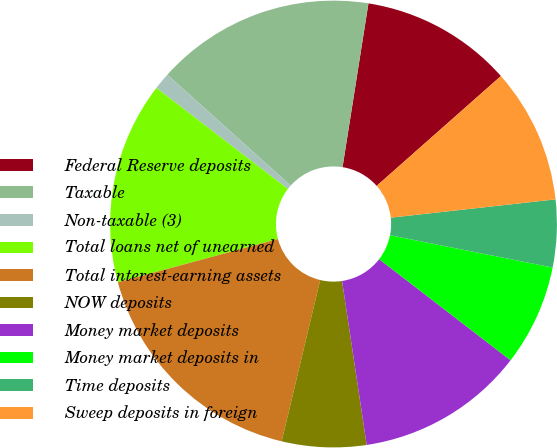Convert chart to OTSL. <chart><loc_0><loc_0><loc_500><loc_500><pie_chart><fcel>Federal Reserve deposits<fcel>Taxable<fcel>Non-taxable (3)<fcel>Total loans net of unearned<fcel>Total interest-earning assets<fcel>NOW deposits<fcel>Money market deposits<fcel>Money market deposits in<fcel>Time deposits<fcel>Sweep deposits in foreign<nl><fcel>10.98%<fcel>15.85%<fcel>1.22%<fcel>14.63%<fcel>17.07%<fcel>6.1%<fcel>12.19%<fcel>7.32%<fcel>4.88%<fcel>9.76%<nl></chart> 